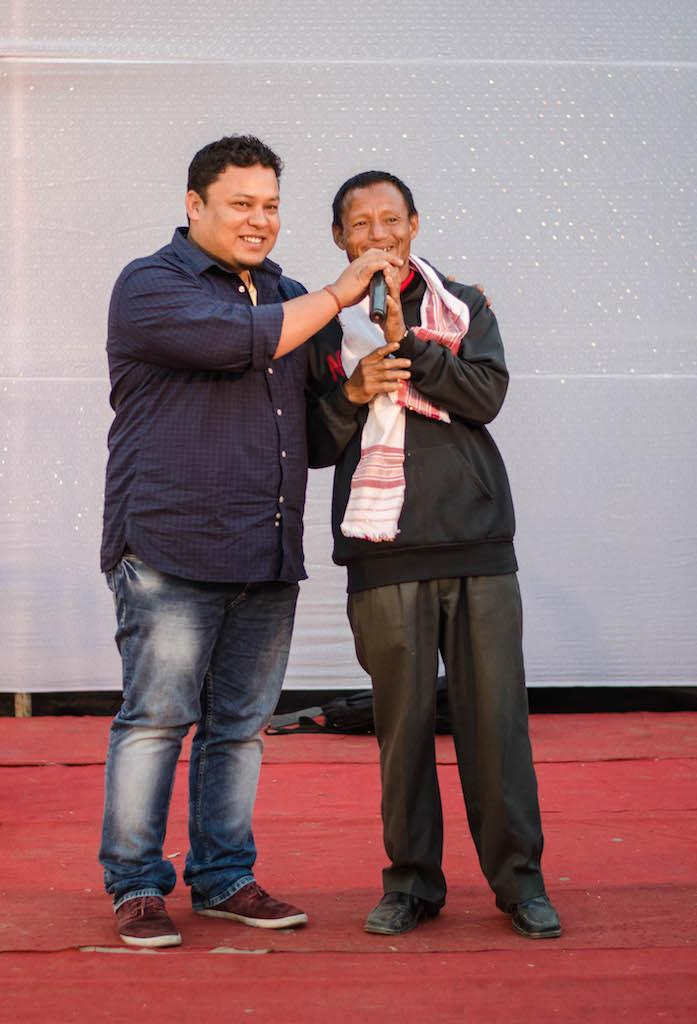How many people are present in the image? There are two people in the image. Where are the two people located? The two people are standing on a stage. What is one of the people holding? One of the people is holding a microphone. What is the person holding the microphone doing? The person holding the microphone is allowing the other person to speak into it. What type of fireman is visible in the image? There is no fireman present in the image. Is there a battle taking place on the stage in the image? There is no battle present in the image; it features two people standing on a stage. 